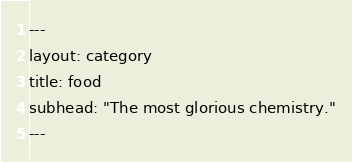<code> <loc_0><loc_0><loc_500><loc_500><_HTML_>---
layout: category
title: food
subhead: "The most glorious chemistry."
---</code> 